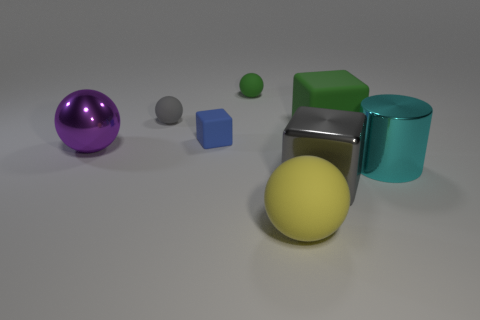Subtract all gray rubber balls. How many balls are left? 3 Subtract all blocks. How many objects are left? 5 Add 1 large metallic objects. How many objects exist? 9 Subtract all yellow rubber things. Subtract all blue matte objects. How many objects are left? 6 Add 6 tiny matte spheres. How many tiny matte spheres are left? 8 Add 8 big metallic spheres. How many big metallic spheres exist? 9 Subtract all yellow spheres. How many spheres are left? 3 Subtract 0 red balls. How many objects are left? 8 Subtract 1 cylinders. How many cylinders are left? 0 Subtract all blue cubes. Subtract all red cylinders. How many cubes are left? 2 